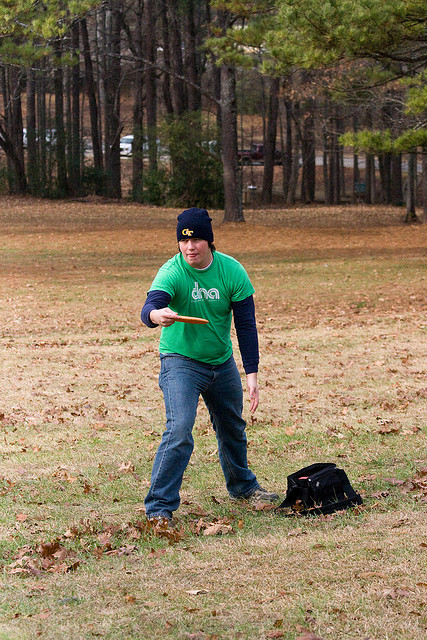Read all the text in this image. dna ar 